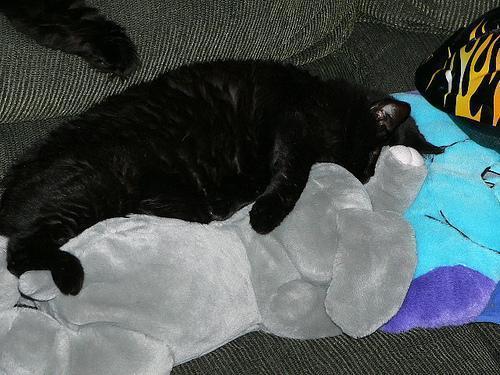How many cats are in the image?
Give a very brief answer. 1. How many trucks are crushing on the street?
Give a very brief answer. 0. 